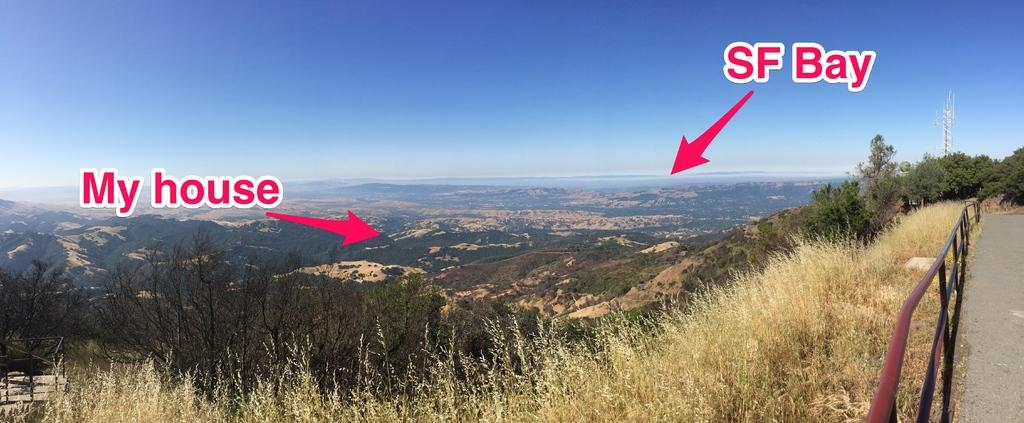<image>
Share a concise interpretation of the image provided. My house is a short distance away from San Francisco bay. 